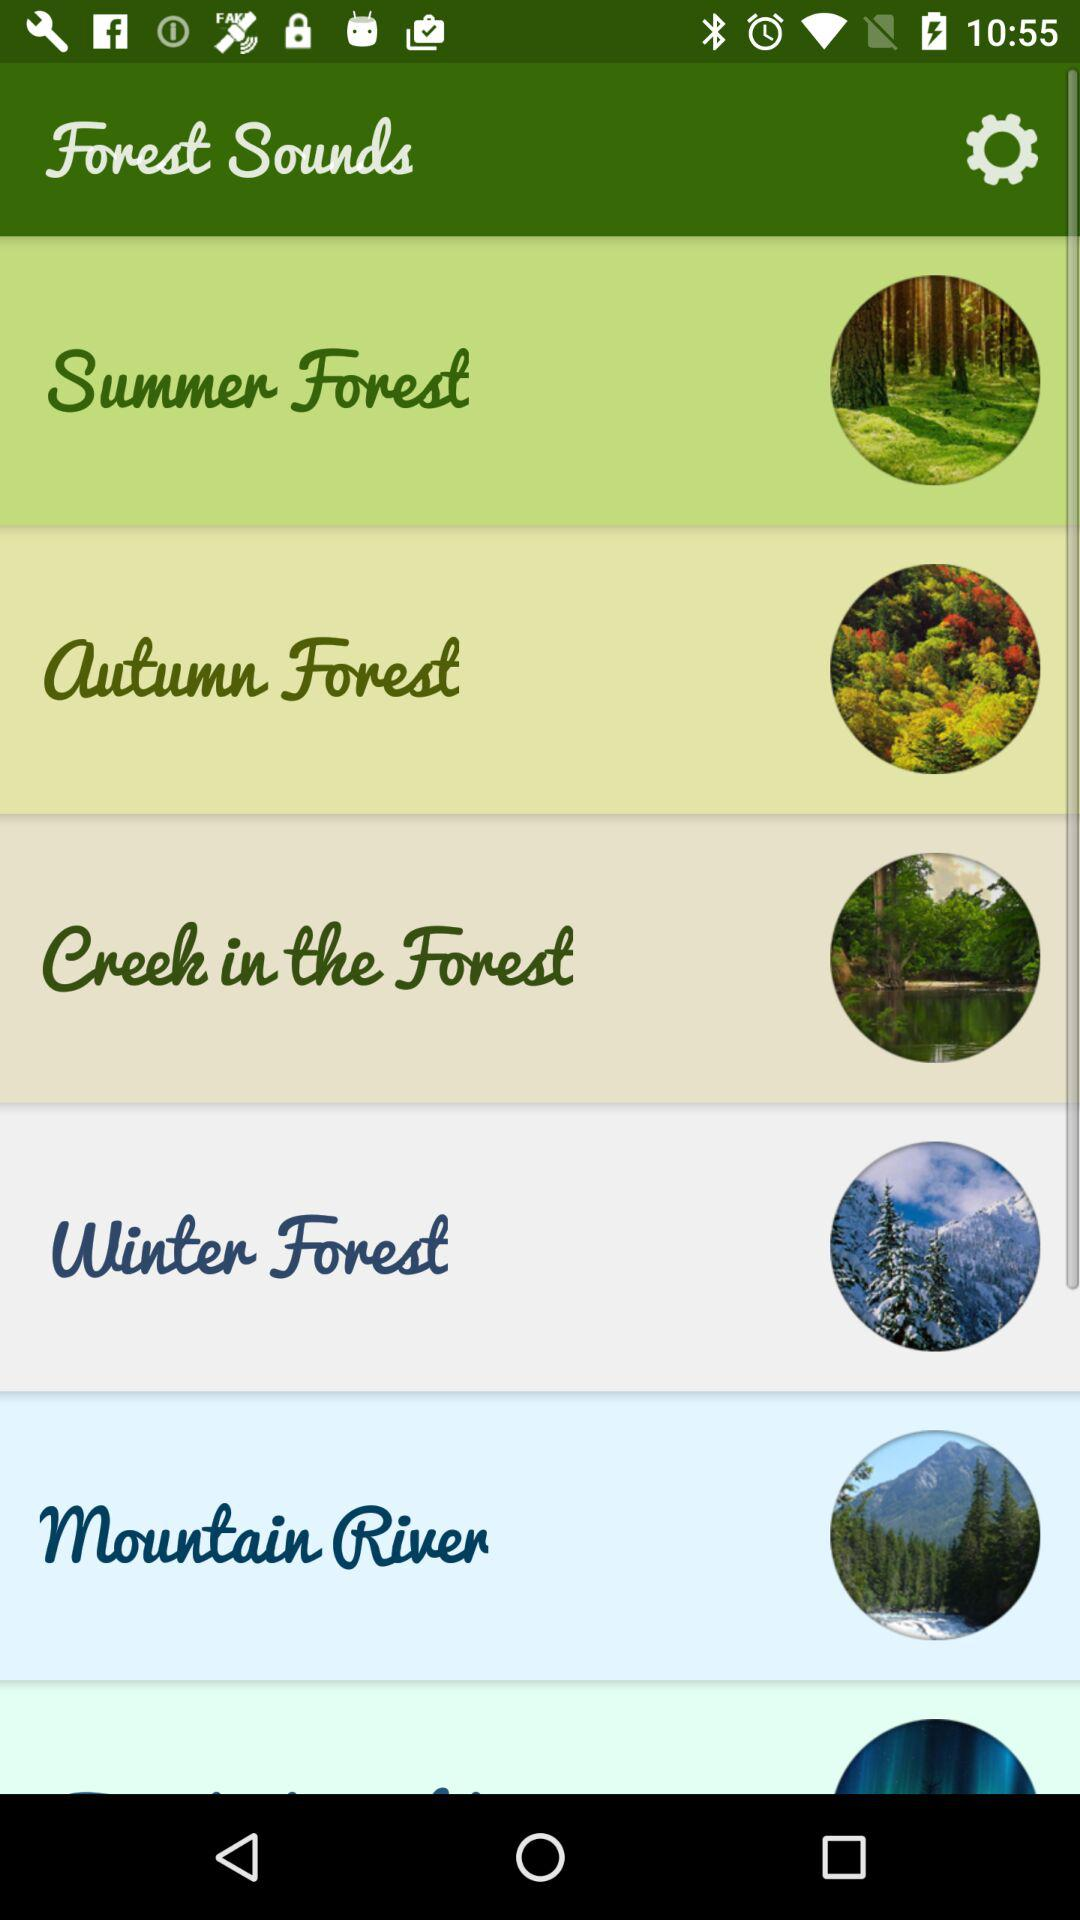What is the application name? The application name is "Forest Sounds". 